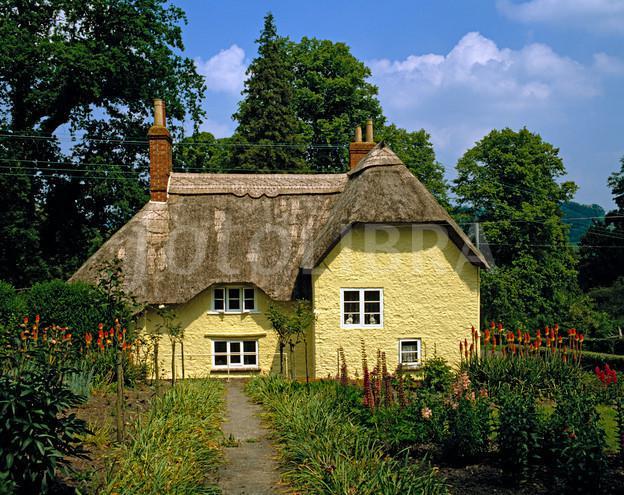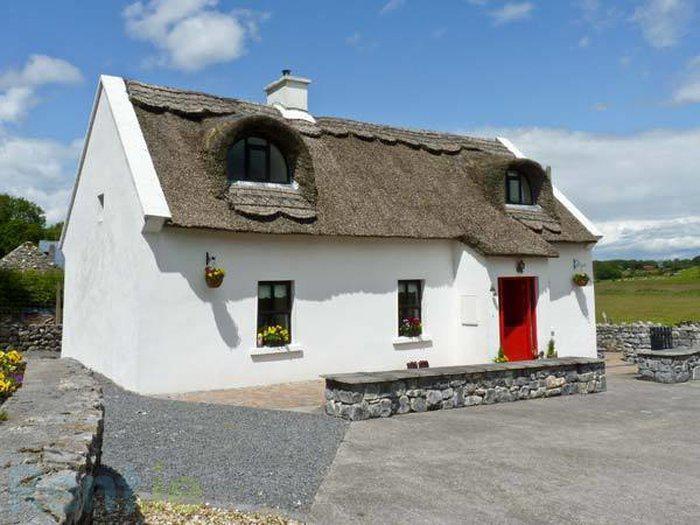The first image is the image on the left, the second image is the image on the right. Examine the images to the left and right. Is the description "At least one of the 2 houses has a wooden fence around it." accurate? Answer yes or no. No. The first image is the image on the left, the second image is the image on the right. Examine the images to the left and right. Is the description "One of the houses has two chimneys, one on each end of the roof line." accurate? Answer yes or no. Yes. 